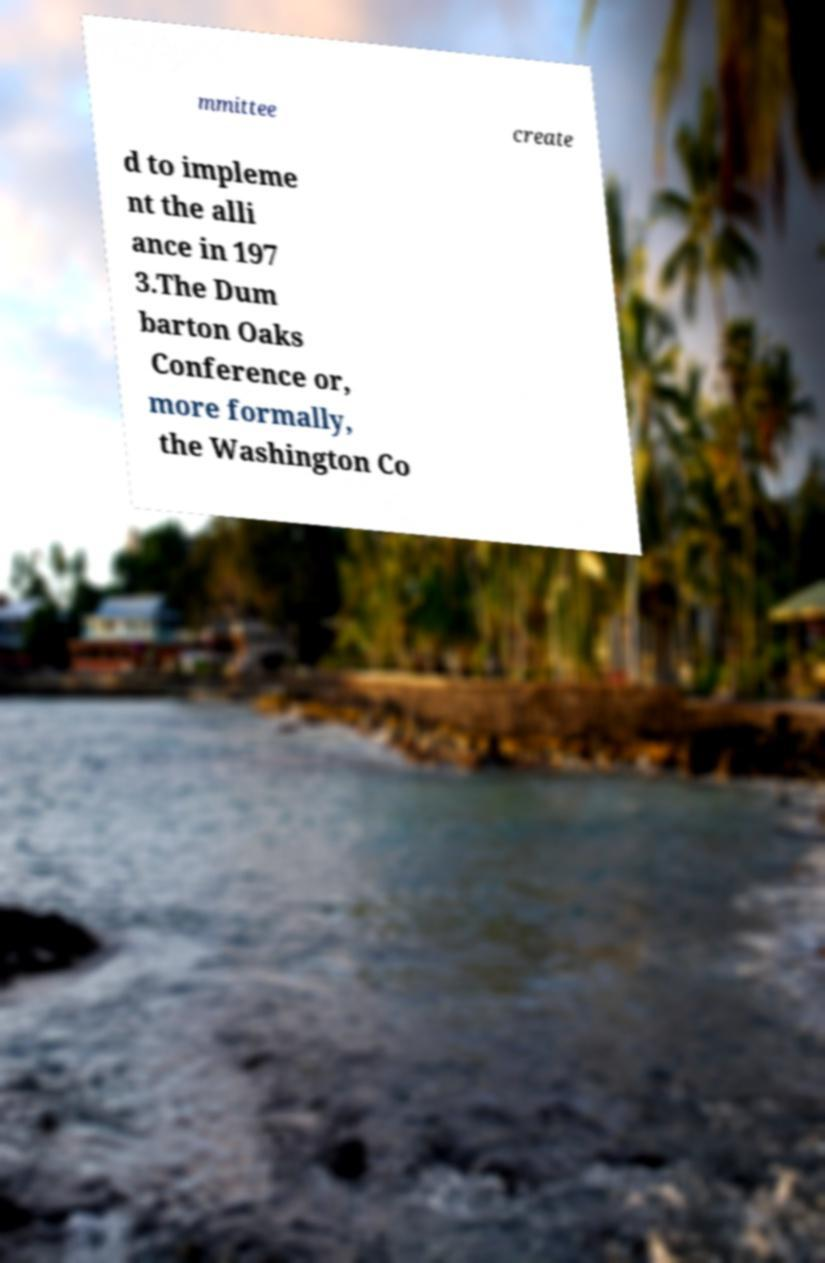I need the written content from this picture converted into text. Can you do that? mmittee create d to impleme nt the alli ance in 197 3.The Dum barton Oaks Conference or, more formally, the Washington Co 